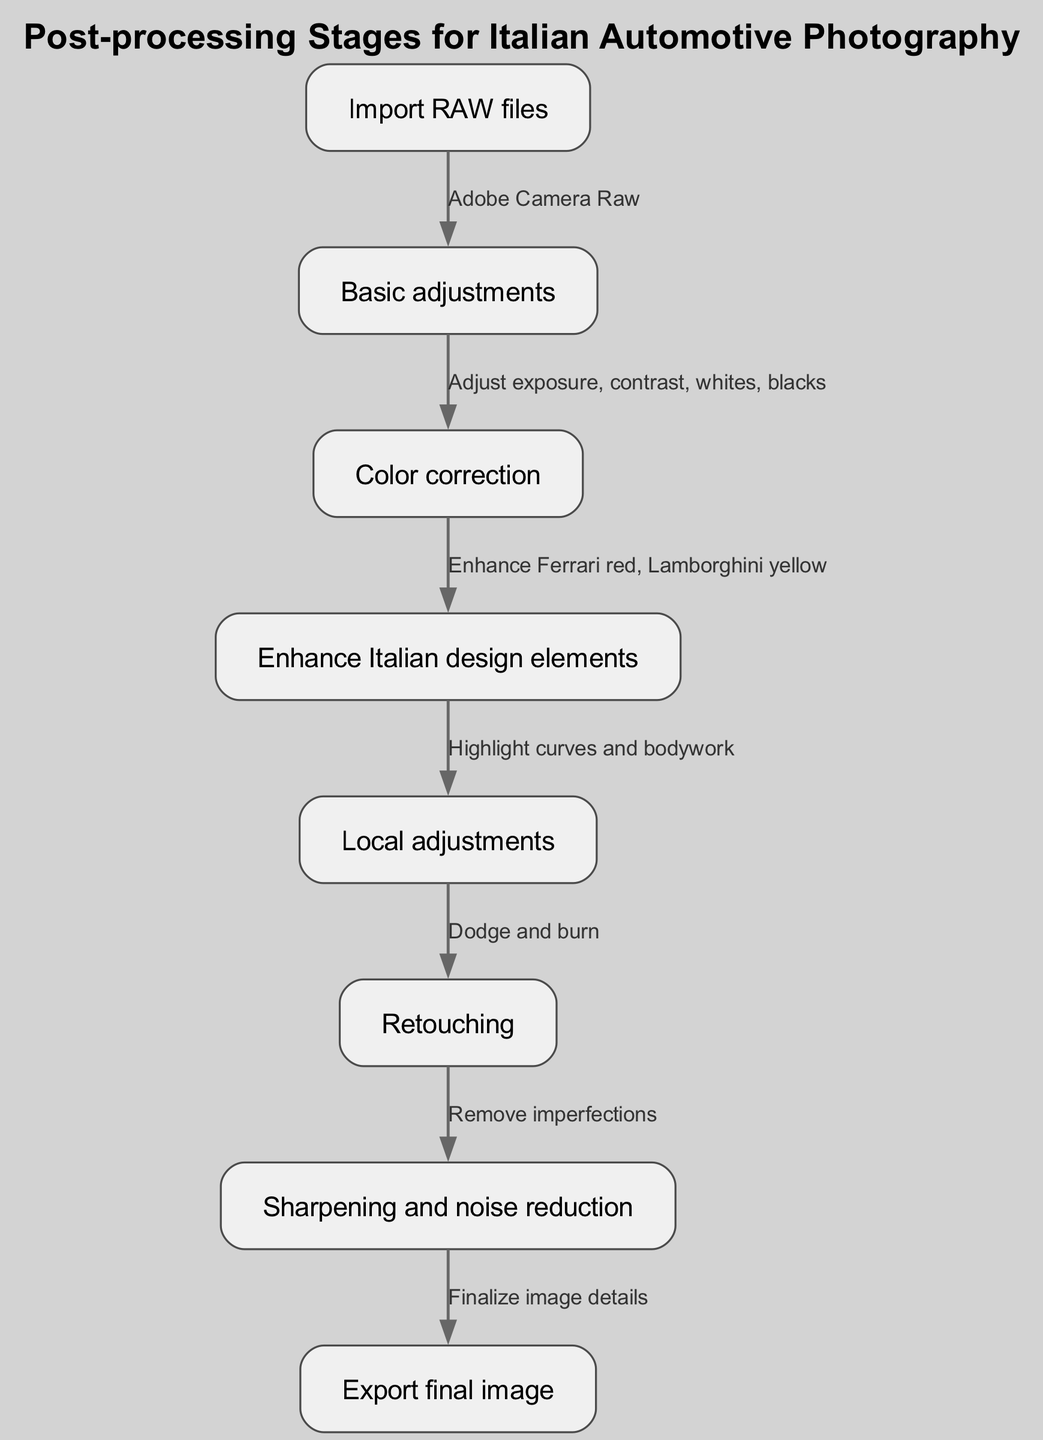What is the first stage in the post-processing workflow? The first stage is indicated as "Import RAW files", which is the entry point for beginning the post-processing of images.
Answer: Import RAW files How many nodes are present in the diagram? By counting the nodes listed in the diagram, we see that there are eight nodes total, all representing different stages in the post-processing workflow.
Answer: Eight What is the last process before exporting the final image? The last process before export is "Sharpening and noise reduction", which ensures that the image details are finalized for the output.
Answer: Sharpening and noise reduction What adjustment follows color correction in the workflow? The workflow shows that after "Color correction", the next adjustment is "Enhance Italian design elements", indicating that color corrections are made prior to emphasizing design features.
Answer: Enhance Italian design elements What technique is used after local adjustments? After "Local adjustments", the technique employed is "Retouching", which typically involves further refinements and corrections to enhance the image quality.
Answer: Retouching Which node emphasizes enhancing specific colors associated with Italian car designs? The node labeled "Enhance Italian design elements" specifically focuses on enhancing colors like Ferrari red and Lamborghini yellow, which are signature colors in Italian automotive design.
Answer: Enhance Italian design elements Which two processes are interconnected directly with arrows in the diagram? "Basic adjustments" connects directly to "Color correction", and "Enhance Italian design elements" connects directly to "Local adjustments", indicating these processes logically follow one another in the workflow.
Answer: Basic adjustments and Color correction, Enhance Italian design elements and Local adjustments Which adjustment involves techniques such as dodging and burning? The "Retouching" process involves techniques like dodging and burning, which are used to selectively lighten or darken areas in the image to enhance overall quality.
Answer: Retouching What type of adjustments are made to highlight curves and bodywork? The "Local adjustments" stage specifically targets highlighting curves and bodywork, focusing on enhancing the aesthetic features of the car.
Answer: Local adjustments 